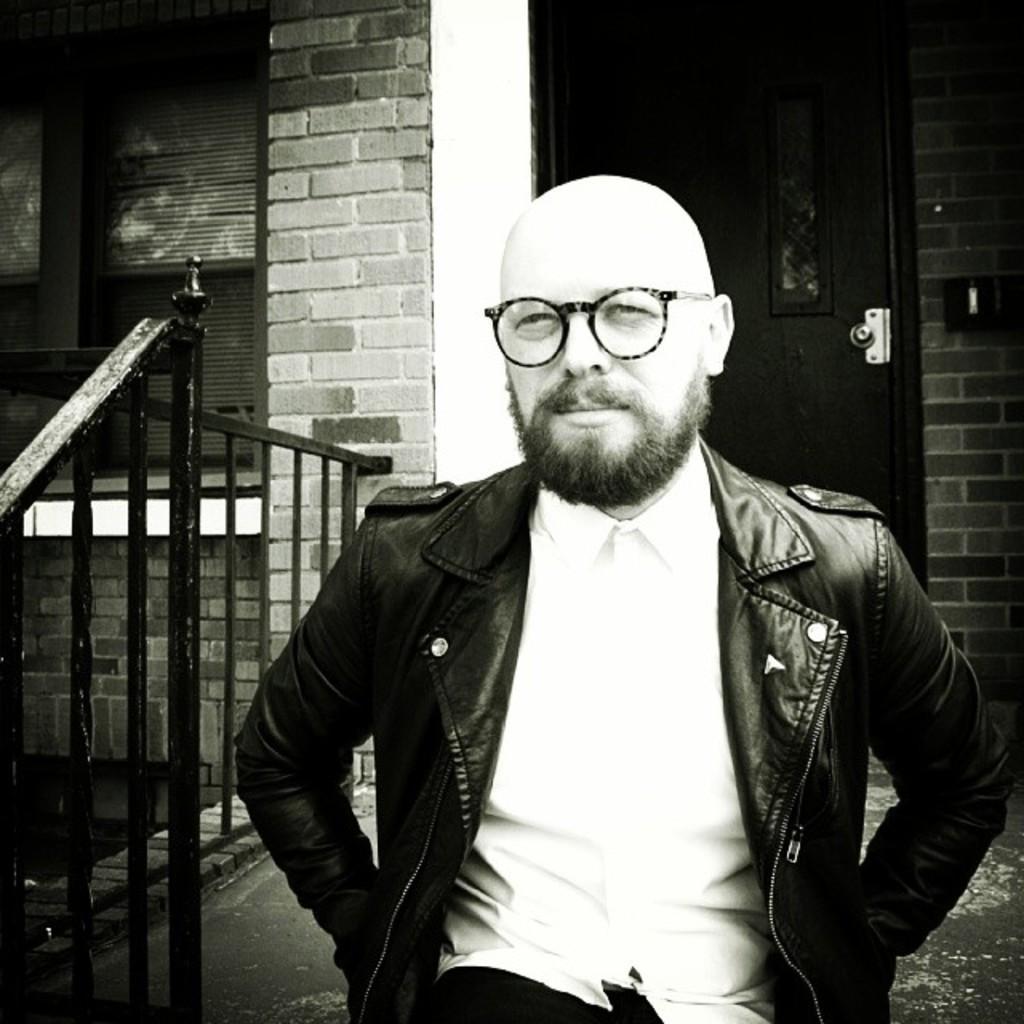Can you describe this image briefly? In this image we can see a person. Behind the person we can see a wall of a building. On the wall we can see a door on the right side. On the left side, we can see a window and a railing. 